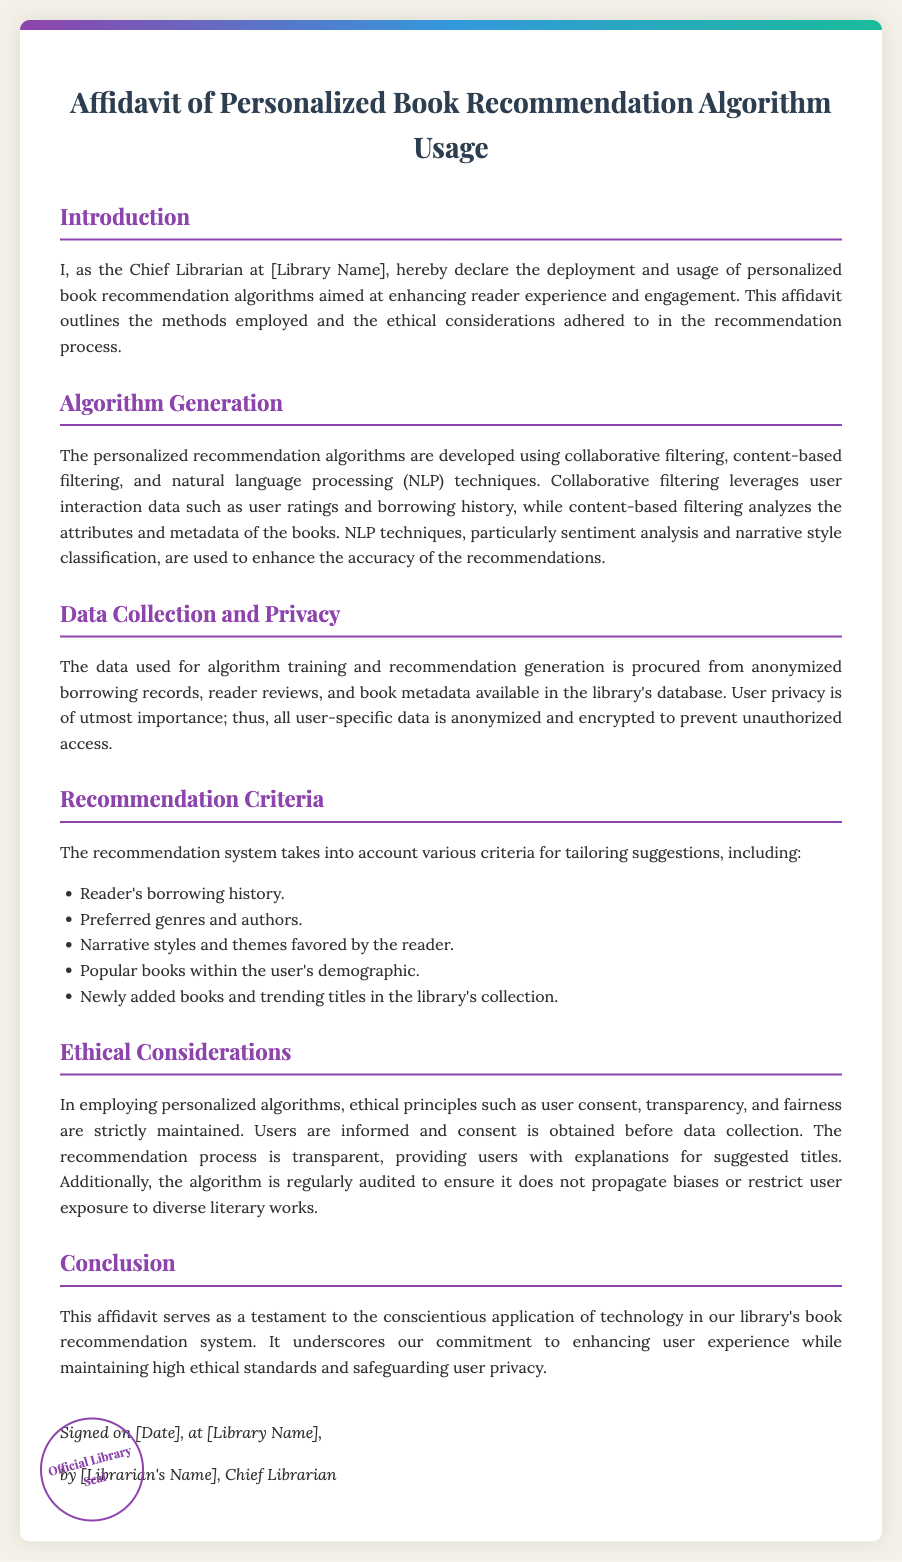What is the title of the affidavit? The title of the affidavit is prominently displayed at the top of the document.
Answer: Affidavit of Personalized Book Recommendation Algorithm Usage Who is the Chief Librarian? The Chief Librarian's role is mentioned in the introduction of the affidavit.
Answer: [Librarian's Name] What techniques are used in the algorithm generation? The document outlines the methods employed for developing the personalized recommendation algorithms.
Answer: Collaborative filtering, content-based filtering, and natural language processing What type of data is used for algorithm training? The section on data collection and privacy details the types of data used.
Answer: Anonymized borrowing records, reader reviews, and book metadata What is the primary ethical principle emphasized in the affidavit? The ethical considerations part of the document outlines the key principles maintained during the recommendation process.
Answer: User consent What factors are considered in the recommendation criteria? The document lists various criteria for tailoring suggestions in a bulleted list.
Answer: Reader's borrowing history, preferred genres and authors, narrative styles and themes favored by the reader, popular books within the user's demographic, newly added books and trending titles On what date is the affidavit signed? The signature section of the document contains a placeholder for the date of signing.
Answer: [Date] What is included at the bottom left of the affidavit? The document describes a visual element present in the design of the affidavit.
Answer: Official Library Seal 